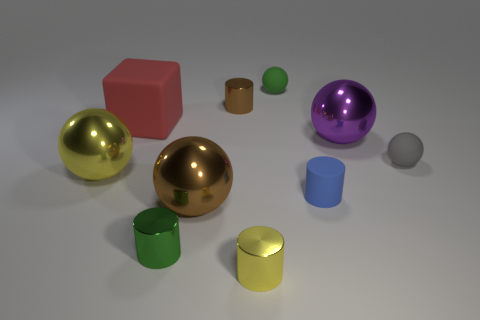Subtract all small yellow cylinders. How many cylinders are left? 3 Subtract all blocks. How many objects are left? 9 Subtract 1 blocks. How many blocks are left? 0 Subtract all large purple rubber balls. Subtract all tiny metal cylinders. How many objects are left? 7 Add 5 small yellow metallic cylinders. How many small yellow metallic cylinders are left? 6 Add 9 big yellow matte cubes. How many big yellow matte cubes exist? 9 Subtract all purple balls. How many balls are left? 4 Subtract 1 green cylinders. How many objects are left? 9 Subtract all red balls. Subtract all cyan cylinders. How many balls are left? 5 Subtract all red blocks. How many gray spheres are left? 1 